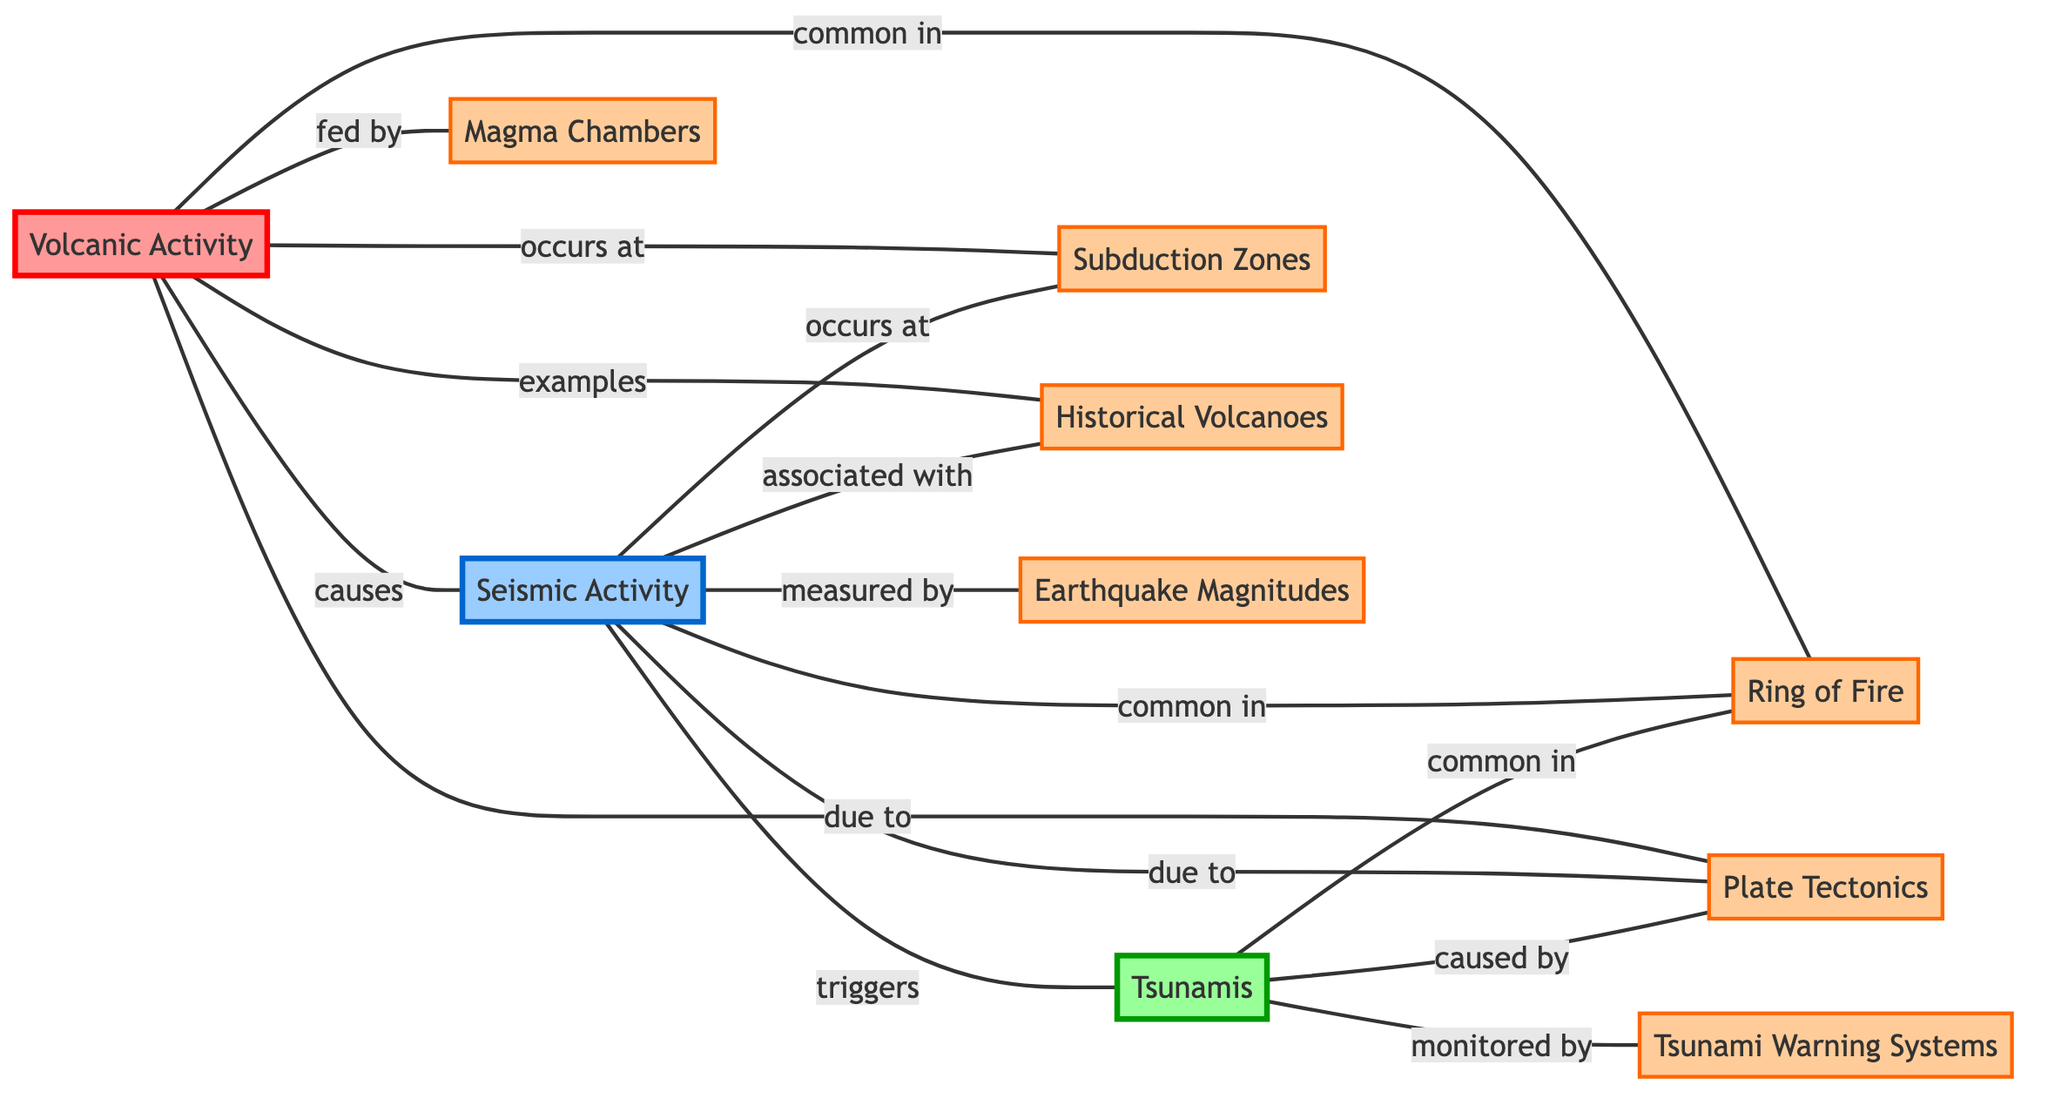What are the examples of Volcanic Activity? The diagram indicates that Volcanic Activity is associated with Historical Volcanoes as one of its examples. Therefore, the answer is Historical Volcanoes.
Answer: Historical Volcanoes How many nodes are in the diagram? By counting the unique nodes listed, there are a total of ten nodes present in the diagram.
Answer: 10 Which activity does not occur at Subduction Zones? The diagram shows that both Volcanic Activity and Seismic Activity occur at Subduction Zones, while Tsunamis are monitored but do not directly occur at these zones. Thus, the answer is Tsunamis.
Answer: Tsunamis What does Seismic Activity measure? According to the diagram, Seismic Activity is measured by Earthquake Magnitudes, which describes the strength of earthquakes associated with this activity.
Answer: Earthquake Magnitudes Which three phenomena are common in the Ring of Fire? The diagram demonstrates that Volcanic Activity, Seismic Activity, and Tsunamis are all stated to be common in the Ring of Fire. Therefore, the answer would be these three distinct activities.
Answer: Volcanic Activity, Seismic Activity, Tsunamis What causes Tsunamis? The diagram illustrates that Tsunamis are caused by interaction with Plate Tectonics, as specified between Tsunamis and Plate Tectonics.
Answer: Plate Tectonics Which node is fed by Magma Chambers? The diagram clearly indicates that Volcanic Activity is fed by Magma Chambers, establishing a direct relationship between the two.
Answer: Volcanic Activity What triggers Tsunamis? The relationship shown in the diagram indicates that Seismic Activity triggers Tsunamis, outlining a causative link between these two activities.
Answer: Seismic Activity Which systems monitor Tsunamis? According to the diagram, Tsunami Warning Systems are responsible for monitoring Tsunamis, showing a clear connection between them.
Answer: Tsunami Warning Systems 